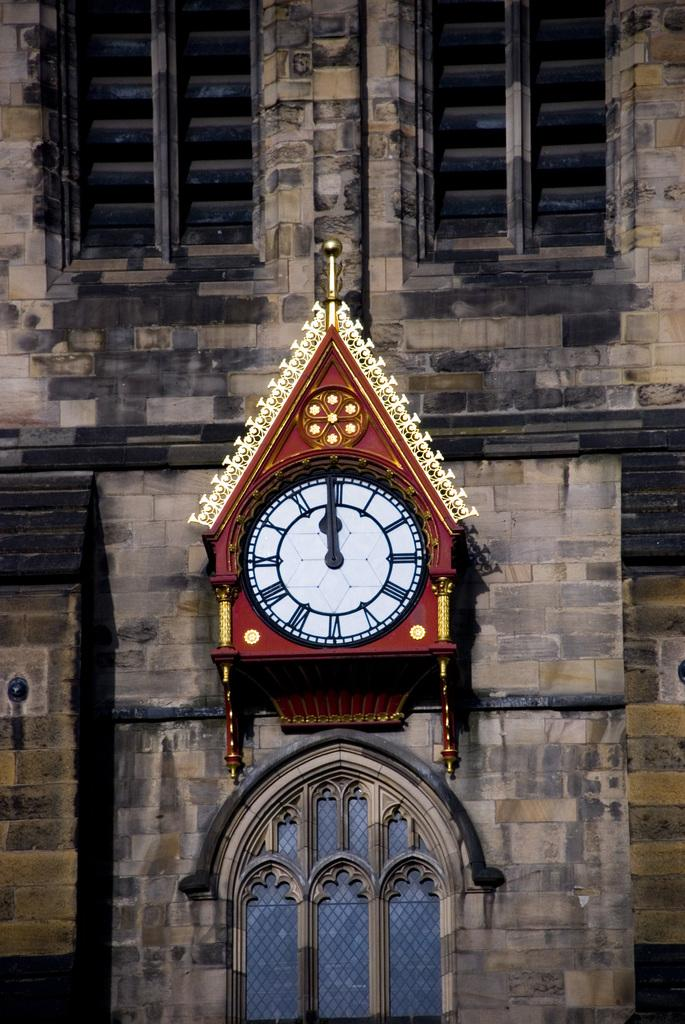<image>
Share a concise interpretation of the image provided. No text in this picture, but the ornate clock reads 12 o clock in Roman numerals. 